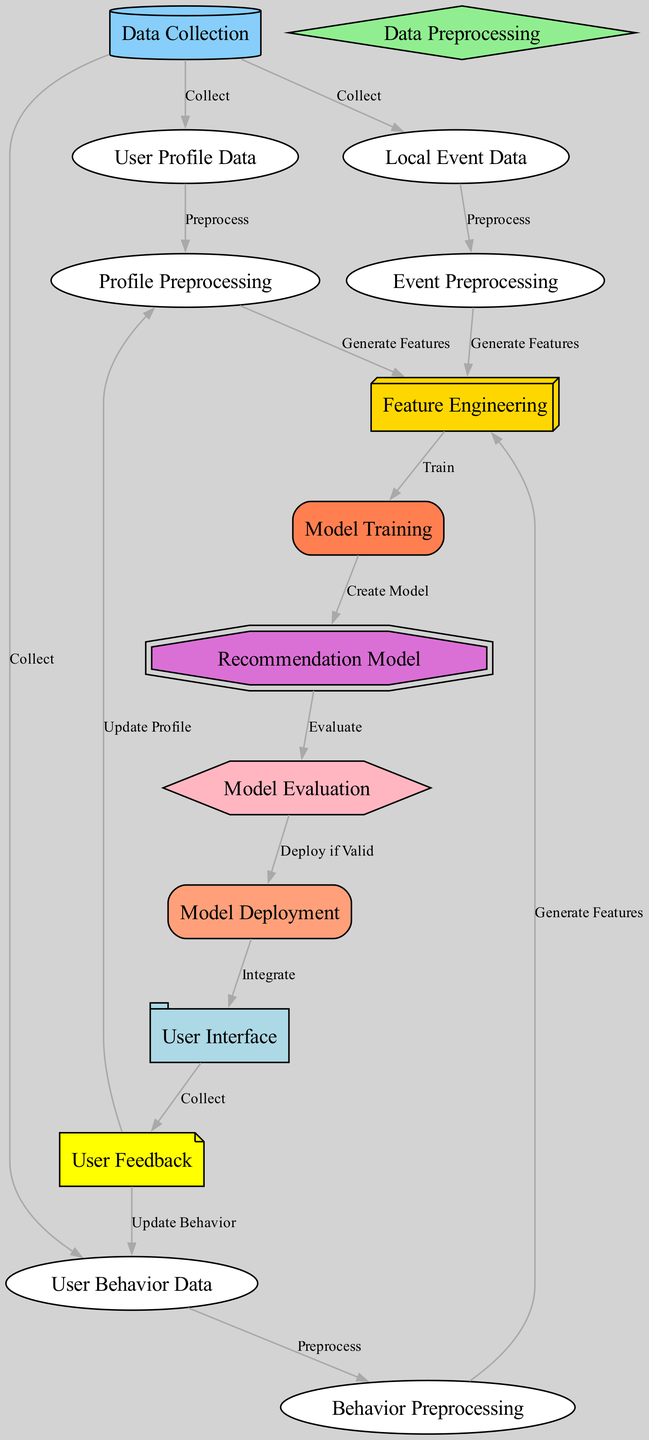What is the first step in the process? The diagram shows that "Data Collection" is the starting node, indicating that this is the first step where data is gathered.
Answer: Data Collection How many nodes are there in total? By counting the distinct nodes listed in the diagram (each representing a component of the recommendation system), we find there are 15 nodes in total.
Answer: 15 What type of data is collected for the user profile? The diagram labels one of the nodes as "User Profile Data," indicating that this is the specific type of data collected related to the users.
Answer: User Profile Data Which nodes involve preprocessing? The diagram has three nodes specifically for preprocessing: "Profile Preprocessing," "Event Preprocessing," and "Behavior Preprocessing." Each corresponds to different data types being cleaned and prepared for analysis.
Answer: Profile Preprocessing, Event Preprocessing, Behavior Preprocessing What happens after model training? After "Model Training," the next step outlined in the diagram is "Recommendation Model," indicating that a model is created based on the training completed.
Answer: Recommendation Model Which node collects user feedback? The diagram specifies "User Feedback" as a dedicated node where feedback is collected, implying critical user interaction feedback is gathered there.
Answer: User Feedback How does user feedback affect the diagram? User feedback is connected to both "Update Behavior" and "Update Profile," indicating that feedback influences future user behavior data and the user profile, effectively updating both elements in the system.
Answer: Update Behavior, Update Profile What comes after evaluation of the model? According to the diagram, once the model is evaluated, if it's valid, it proceeds to "Model Deployment," allowing the application of the model in user interactions.
Answer: Model Deployment What type of model is mentioned in the diagram? The diagram specifically refers to a "Recommendation Model," which is designed to provide personalized event recommendations based on the processed data.
Answer: Recommendation Model 